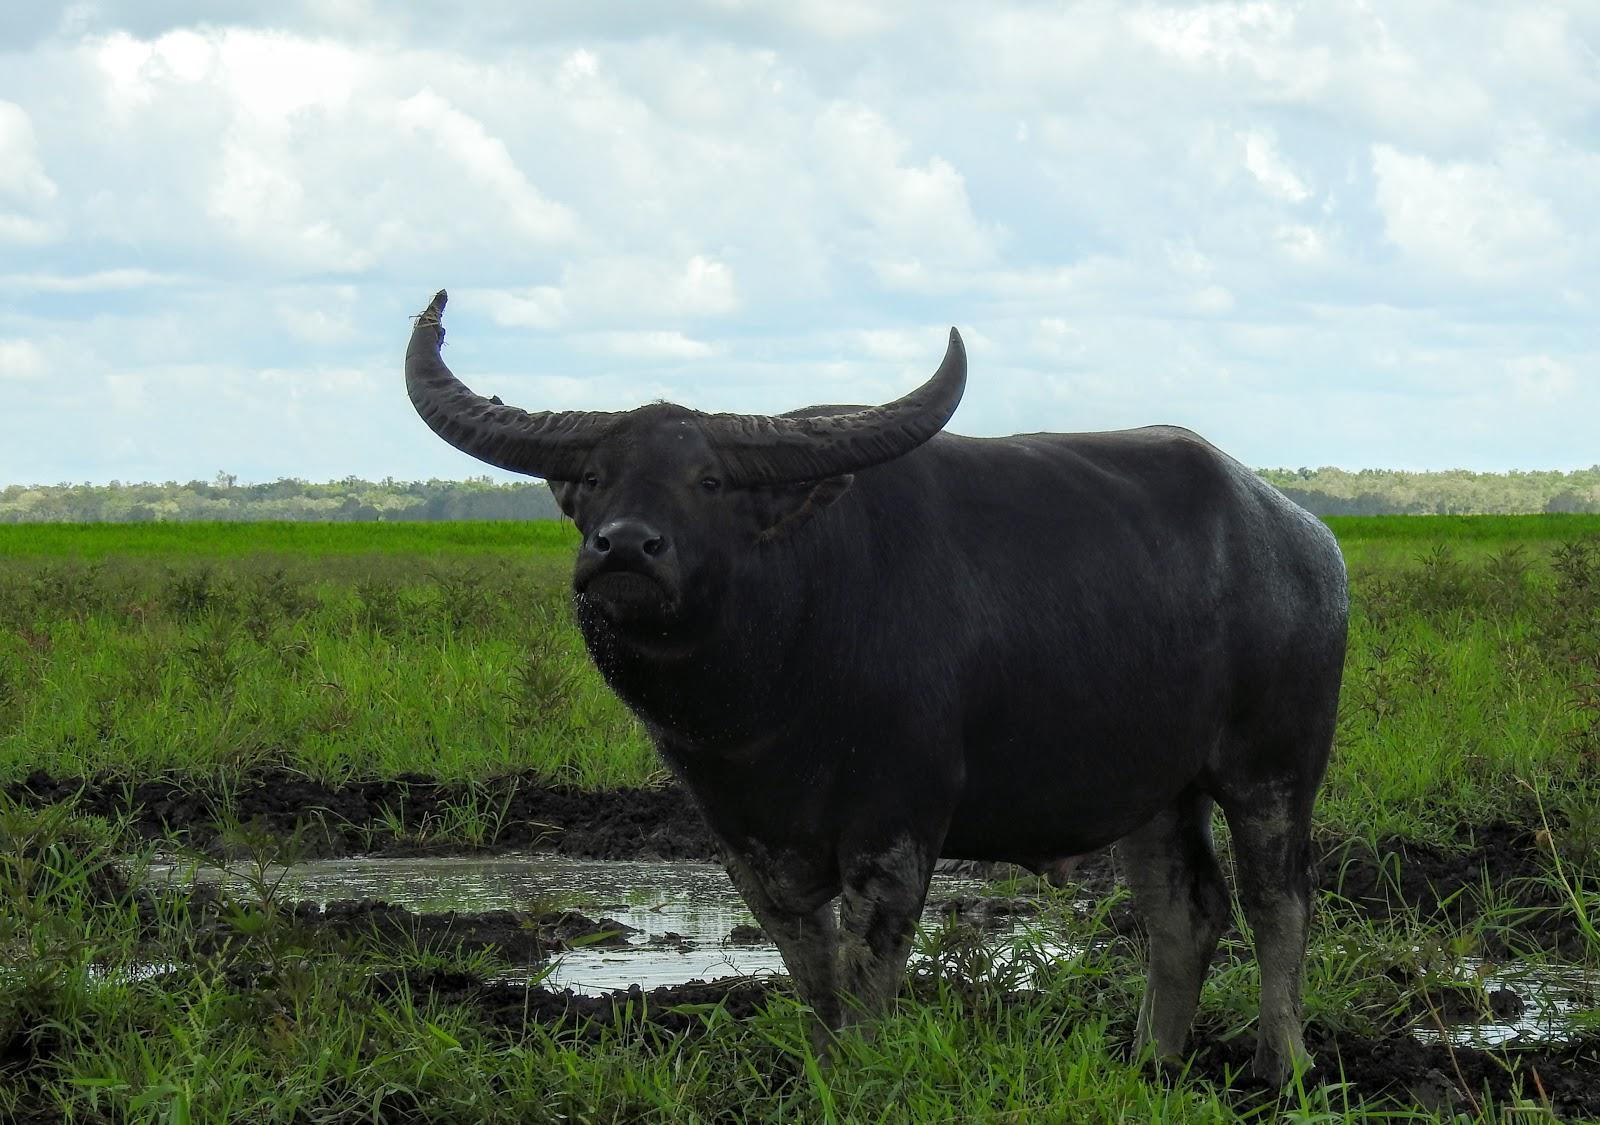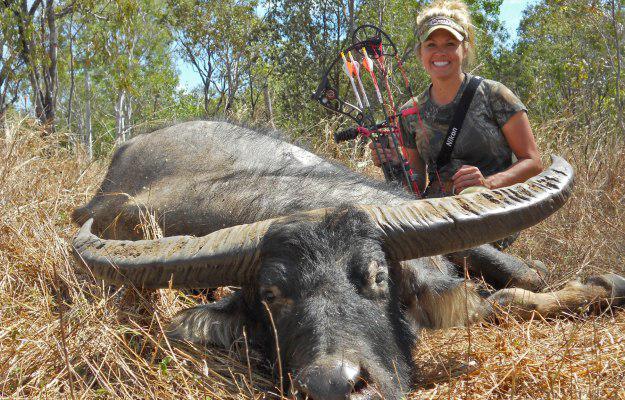The first image is the image on the left, the second image is the image on the right. Given the left and right images, does the statement "A non-standing hunter holding a weapon is behind a killed water buffalo that is lying on the ground with its face forward." hold true? Answer yes or no. Yes. The first image is the image on the left, the second image is the image on the right. Examine the images to the left and right. Is the description "The right image contains a dead water buffalo in front of a human." accurate? Answer yes or no. Yes. 